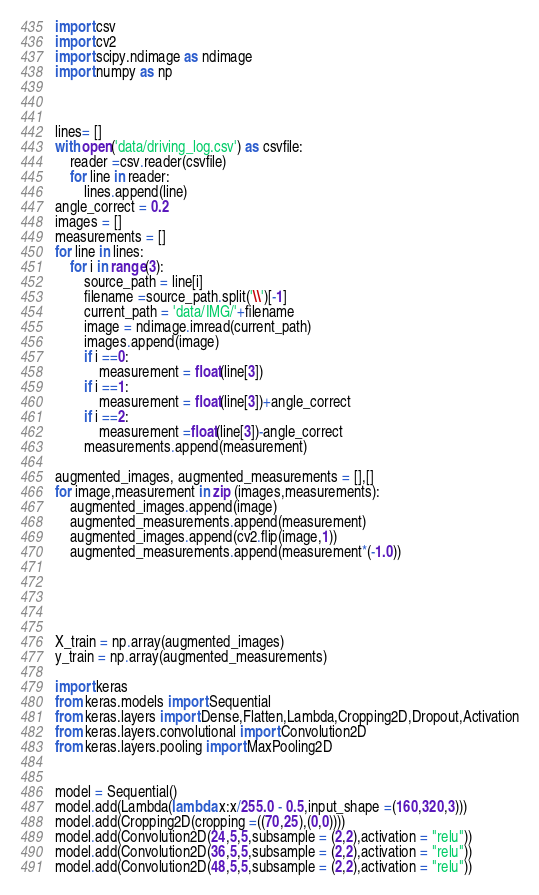<code> <loc_0><loc_0><loc_500><loc_500><_Python_>import csv
import cv2
import scipy.ndimage as ndimage
import numpy as np



lines= []
with open('data/driving_log.csv') as csvfile:
    reader =csv.reader(csvfile)
    for line in reader:
        lines.append(line)
angle_correct = 0.2
images = []
measurements = []
for line in lines:
    for i in range(3):
        source_path = line[i]
        filename =source_path.split('\\')[-1]
        current_path = 'data/IMG/'+filename
        image = ndimage.imread(current_path)
        images.append(image)
        if i ==0:
            measurement = float(line[3])
        if i ==1:
            measurement = float(line[3])+angle_correct
        if i ==2:
            measurement =float(line[3])-angle_correct
        measurements.append(measurement)
  
augmented_images, augmented_measurements = [],[]
for image,measurement in zip (images,measurements):
    augmented_images.append(image)
    augmented_measurements.append(measurement)
    augmented_images.append(cv2.flip(image,1))
    augmented_measurements.append(measurement*(-1.0))
    
                            
                        
    

X_train = np.array(augmented_images)
y_train = np.array(augmented_measurements)

import keras
from keras.models import Sequential
from keras.layers import Dense,Flatten,Lambda,Cropping2D,Dropout,Activation
from keras.layers.convolutional import Convolution2D
from keras.layers.pooling import MaxPooling2D


model = Sequential()
model.add(Lambda(lambda x:x/255.0 - 0.5,input_shape =(160,320,3)))
model.add(Cropping2D(cropping =((70,25),(0,0))))
model.add(Convolution2D(24,5,5,subsample = (2,2),activation = "relu"))
model.add(Convolution2D(36,5,5,subsample = (2,2),activation = "relu"))
model.add(Convolution2D(48,5,5,subsample = (2,2),activation = "relu"))</code> 